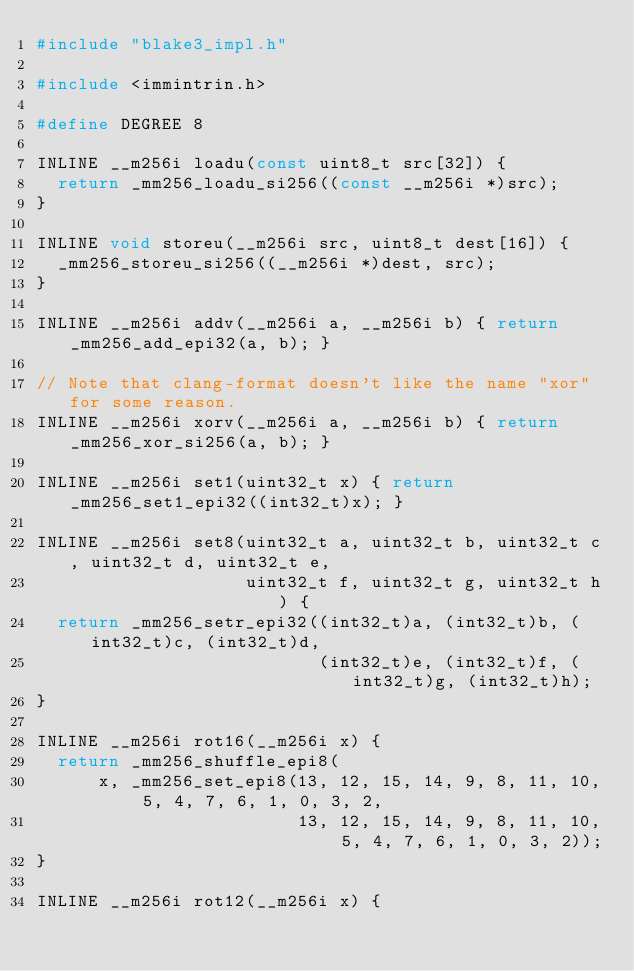Convert code to text. <code><loc_0><loc_0><loc_500><loc_500><_C_>#include "blake3_impl.h"

#include <immintrin.h>

#define DEGREE 8

INLINE __m256i loadu(const uint8_t src[32]) {
  return _mm256_loadu_si256((const __m256i *)src);
}

INLINE void storeu(__m256i src, uint8_t dest[16]) {
  _mm256_storeu_si256((__m256i *)dest, src);
}

INLINE __m256i addv(__m256i a, __m256i b) { return _mm256_add_epi32(a, b); }

// Note that clang-format doesn't like the name "xor" for some reason.
INLINE __m256i xorv(__m256i a, __m256i b) { return _mm256_xor_si256(a, b); }

INLINE __m256i set1(uint32_t x) { return _mm256_set1_epi32((int32_t)x); }

INLINE __m256i set8(uint32_t a, uint32_t b, uint32_t c, uint32_t d, uint32_t e,
                    uint32_t f, uint32_t g, uint32_t h) {
  return _mm256_setr_epi32((int32_t)a, (int32_t)b, (int32_t)c, (int32_t)d,
                           (int32_t)e, (int32_t)f, (int32_t)g, (int32_t)h);
}

INLINE __m256i rot16(__m256i x) {
  return _mm256_shuffle_epi8(
      x, _mm256_set_epi8(13, 12, 15, 14, 9, 8, 11, 10, 5, 4, 7, 6, 1, 0, 3, 2,
                         13, 12, 15, 14, 9, 8, 11, 10, 5, 4, 7, 6, 1, 0, 3, 2));
}

INLINE __m256i rot12(__m256i x) {</code> 